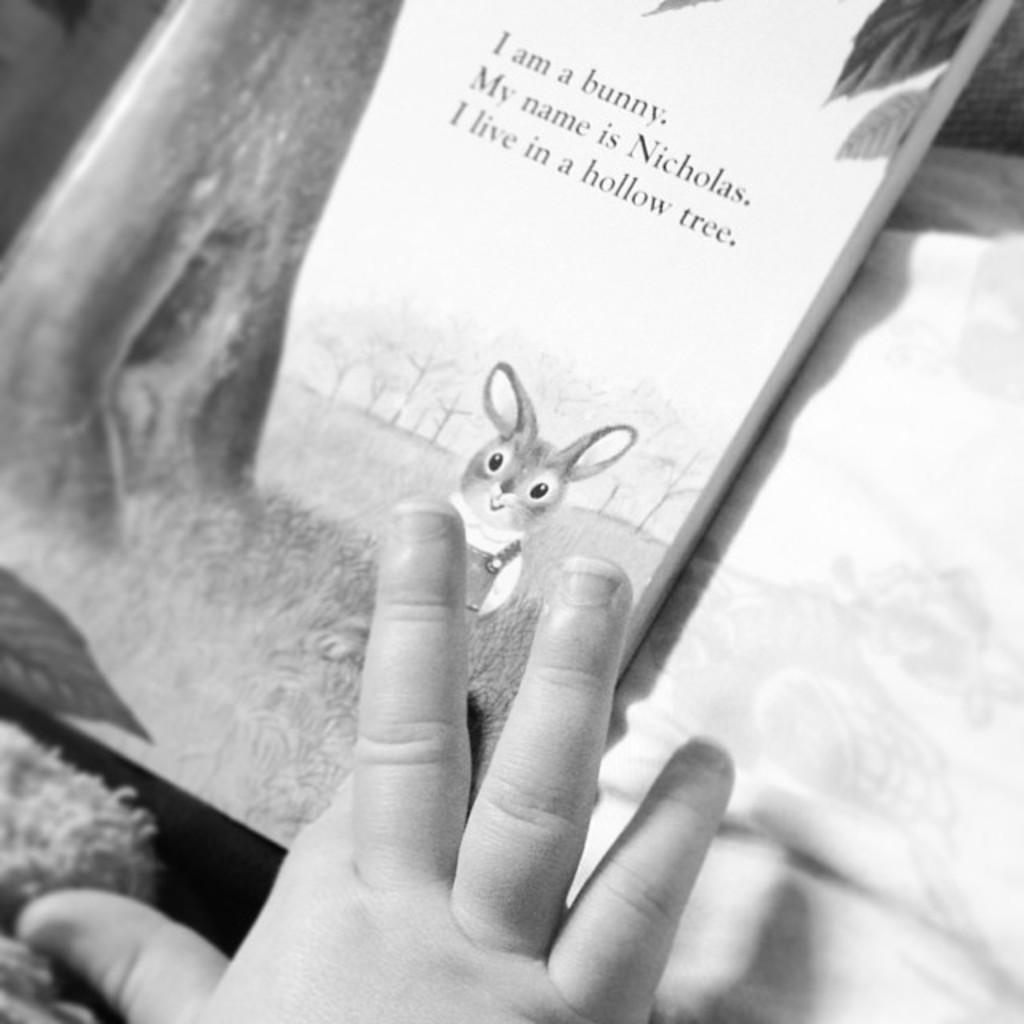What object can be seen in the image? There is a book in the image. Can you describe any other details in the image? A small baby hand is visible in the image. What emotion is the baby expressing with their mouth in the image? There is no mouth visible in the image, as only a small baby hand is mentioned. 